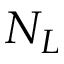Convert formula to latex. <formula><loc_0><loc_0><loc_500><loc_500>N _ { L }</formula> 